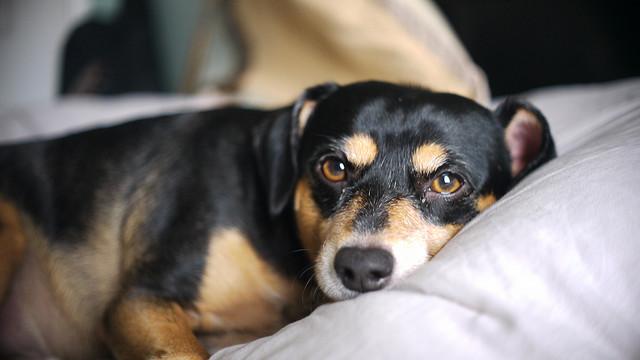Is the dog asleep?
Keep it brief. No. What color is the dog?
Concise answer only. Black and brown. What color are the dog's eyes?
Concise answer only. Brown. 